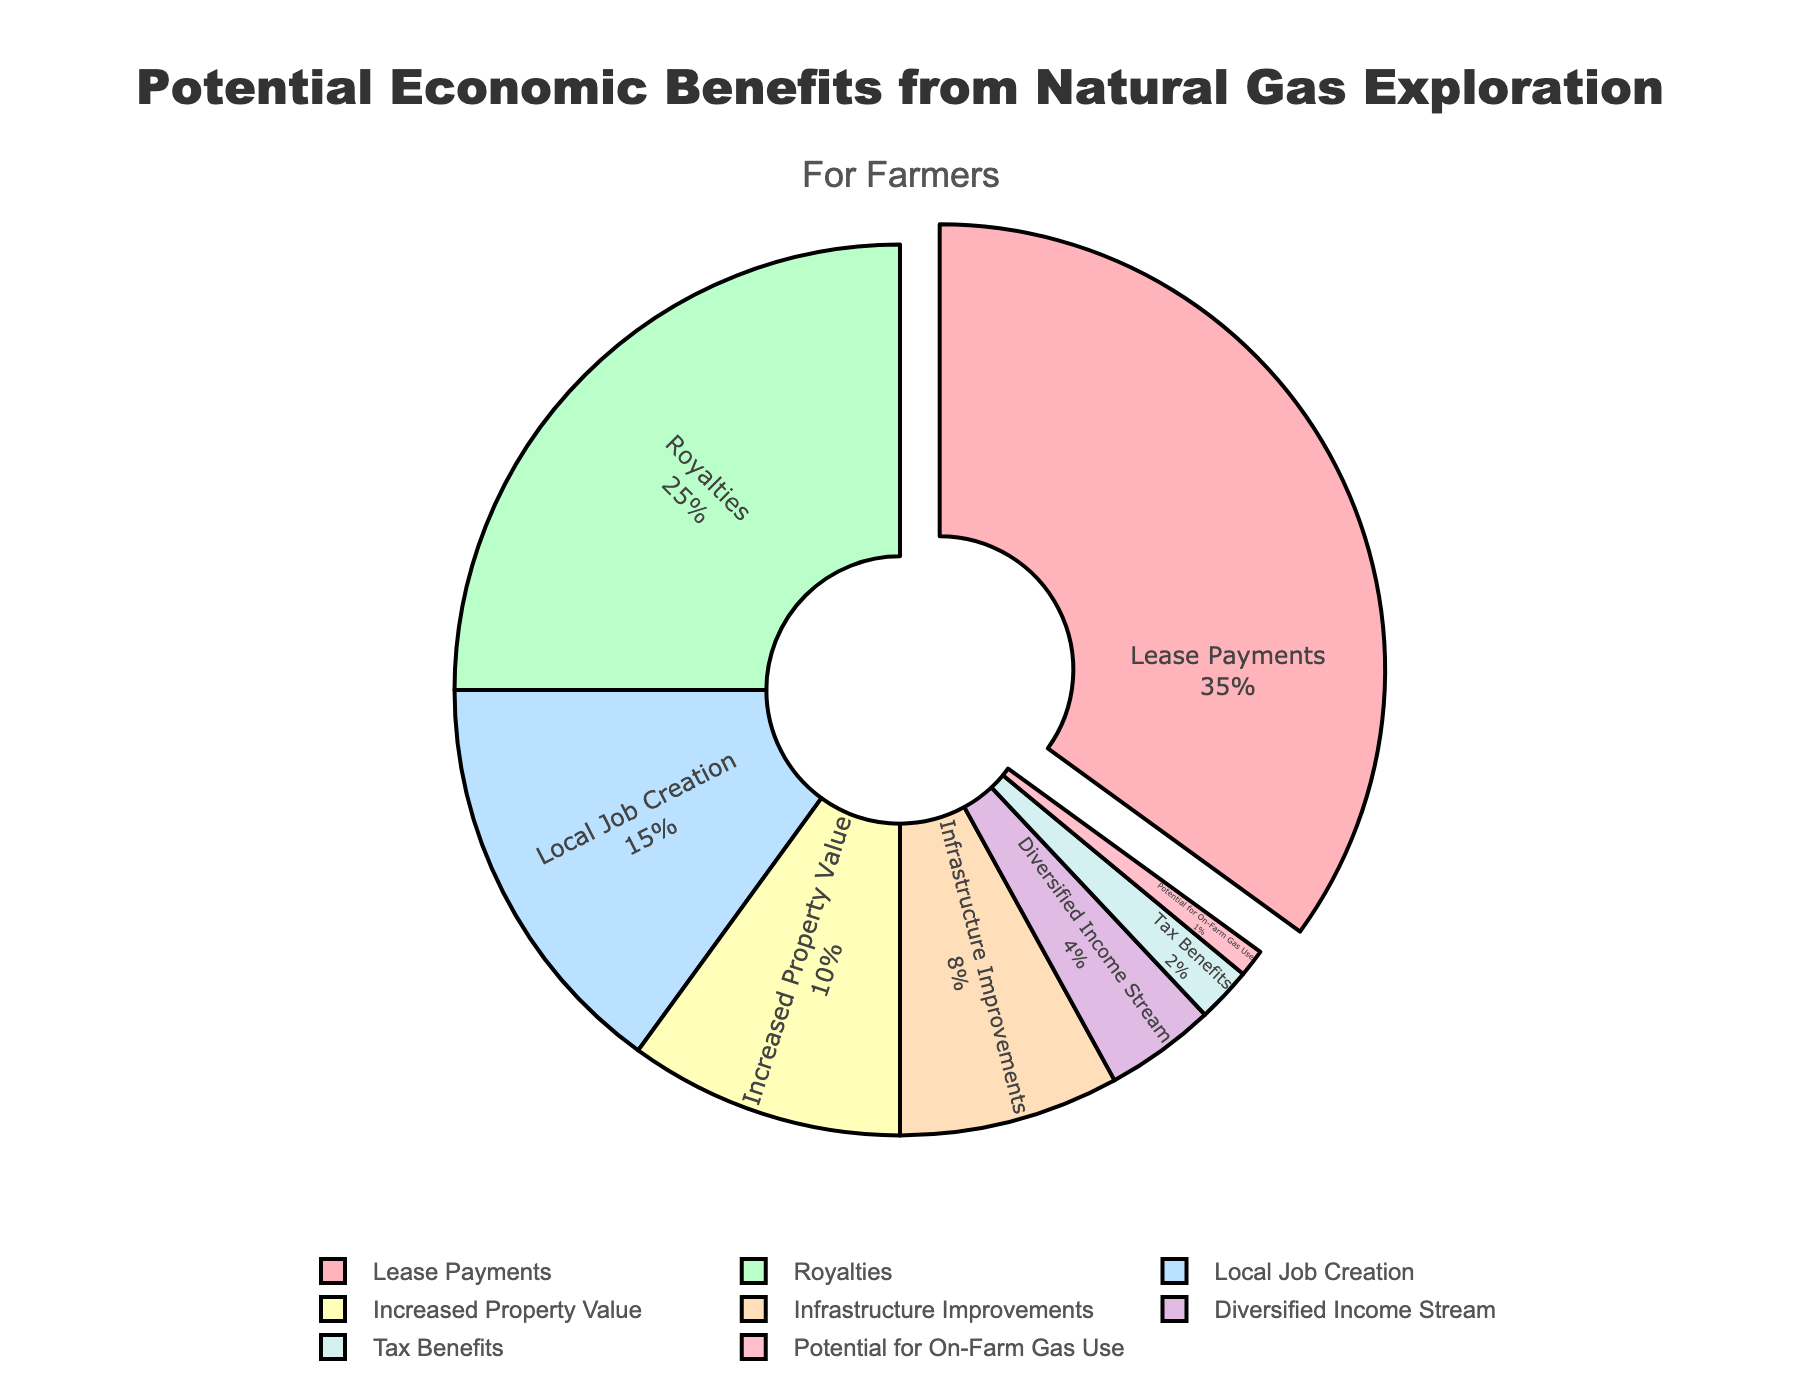How much more percentage does 'Lease Payments' account for compared to 'Royalties'? 'Lease Payments' accounts for 35%, and 'Royalties' accounts for 25%. The difference between them is 35% - 25% = 10%.
Answer: 10% Which category accounts for the smallest percentage? The smallest percentage is 1%, which corresponds to the category 'Potential for On-Farm Gas Use'.
Answer: Potential for On-Farm Gas Use What is the combined percentage of 'Infrastructure Improvements' and 'Increased Property Value'? 'Infrastructure Improvements' is 8% and 'Increased Property Value' is 10%. Combined, they account for 8% + 10% = 18%.
Answer: 18% Is the percentage of 'Local Job Creation' greater than 'Increased Property Value'? 'Local Job Creation' is 15%, and 'Increased Property Value' is 10%. Since 15% is greater than 10%, the answer is yes.
Answer: yes What percentage of benefits account for less than 5% each? 'Diversified Income Stream' is 4%, 'Tax Benefits' is 2%, and 'Potential for On-Farm Gas Use' is 1%. Adding them up: 4% + 2% + 1% = 7%.
Answer: 7% How many categories account for a larger percentage than 'Local Job Creation'? 'Local Job Creation' makes up 15%. The categories larger than this are 'Lease Payments' (35%) and 'Royalties' (25%). There are two categories.
Answer: 2 Which category is highlighted in the pie chart? The category highlighted is 'Lease Payments', as it is the largest sector, accounting for 35%.
Answer: Lease Payments Among 'Lease Payments', 'Royalties', and 'Local Job Creation', which two categories combined make up more than half of the total percentage? 'Lease Payments' is 35% and 'Royalties' is 25%. Combined, they make up 35% + 25% = 60%, which is more than half of the total percentage.
Answer: Lease Payments and Royalties 